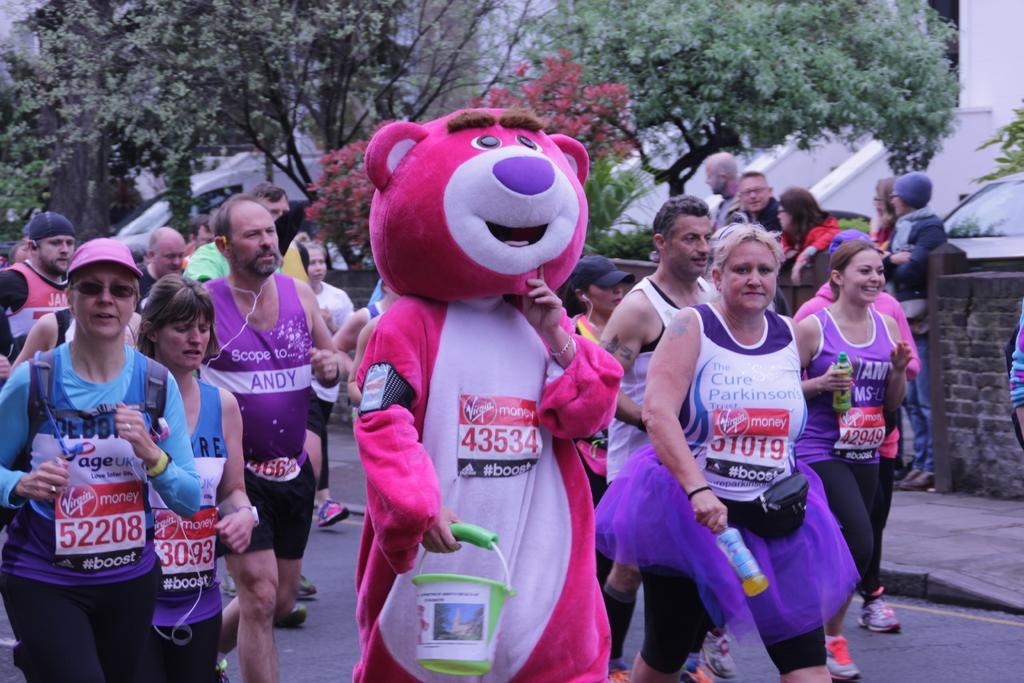In one or two sentences, can you explain what this image depicts? In this image there are group of persons running, there are holding an object, there are group of persons standing, there is a wall towards the right of the image, there is road towards the bottom of the image, there is a vehicle, there are trees towards the top of the image. 